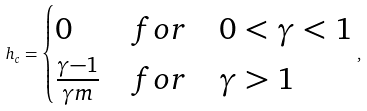<formula> <loc_0><loc_0><loc_500><loc_500>h _ { c } = \begin{cases} 0 & f o r \quad 0 < \gamma < 1 \\ \frac { \gamma - 1 } { \gamma m } & f o r \quad \gamma > 1 \end{cases} ,</formula> 